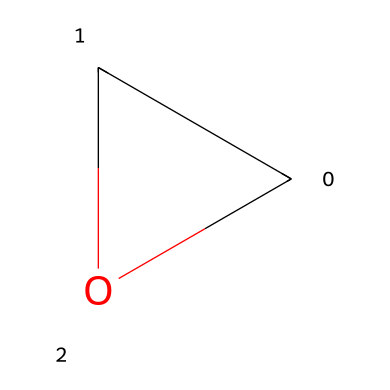How many carbon atoms are present in this structure? The SMILES representation shows "C" indicating the presence of one carbon atom. This directly translates to the molecular structure which visually displays one carbon atom as well.
Answer: one carbon What type of ring does this structure form? The structure consists of a three-membered ring indicated by the cyclic notation "C1CO1" in SMILES, which is characteristic of an epoxide.
Answer: epoxide What functional groups are present in this compound? The presence of an ether linkage is indicated by the arrangement of the carbon and oxygen atoms in a cyclic format, signifying an ether functional group in this compound.
Answer: ether How many atoms are in the ring? Counting atoms in the ring structure reveals two carbons and one oxygen in the three-membered ring, totaling three atoms in that specific portion of the molecule.
Answer: three atoms What is the primary type of reaction that epoxides undergo? Epoxides primarily undergo ring-opening reactions. The structural properties of epoxides make them reactive, especially under nucleophilic attack, leading to this type of reaction.
Answer: ring-opening What is the bond type connecting the carbon and oxygen in the ring? The bond between the carbon and oxygen atoms in the epoxide structure can be determined to be a sigma bond, which is typical for single bonds in molecular structures.
Answer: sigma bond In terms of narrative structure, what might the strain in the epoxide ring symbolize? The strain in the three-membered ring can symbolize tension in a narrative. Just as a character experiences strain before a plot twist, the epoxide's structure is under stress, waiting to resolve in a reaction.
Answer: tension 